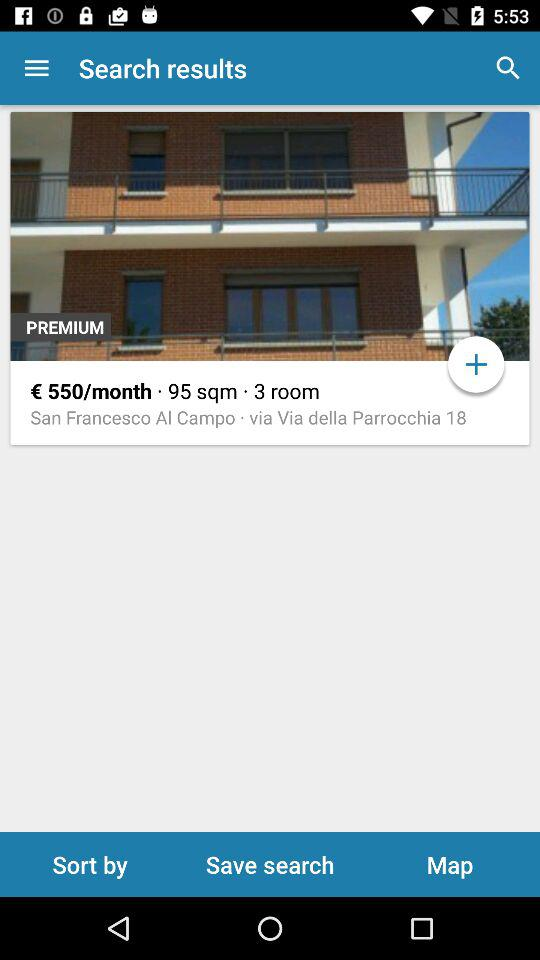What is the area of the building in square metres? The area is 95 square metres. 